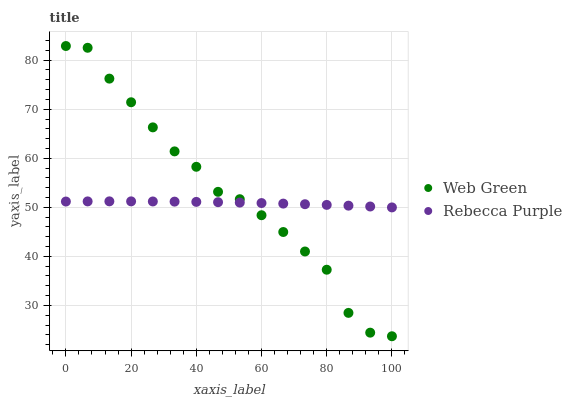Does Rebecca Purple have the minimum area under the curve?
Answer yes or no. Yes. Does Web Green have the maximum area under the curve?
Answer yes or no. Yes. Does Web Green have the minimum area under the curve?
Answer yes or no. No. Is Rebecca Purple the smoothest?
Answer yes or no. Yes. Is Web Green the roughest?
Answer yes or no. Yes. Is Web Green the smoothest?
Answer yes or no. No. Does Web Green have the lowest value?
Answer yes or no. Yes. Does Web Green have the highest value?
Answer yes or no. Yes. Does Rebecca Purple intersect Web Green?
Answer yes or no. Yes. Is Rebecca Purple less than Web Green?
Answer yes or no. No. Is Rebecca Purple greater than Web Green?
Answer yes or no. No. 